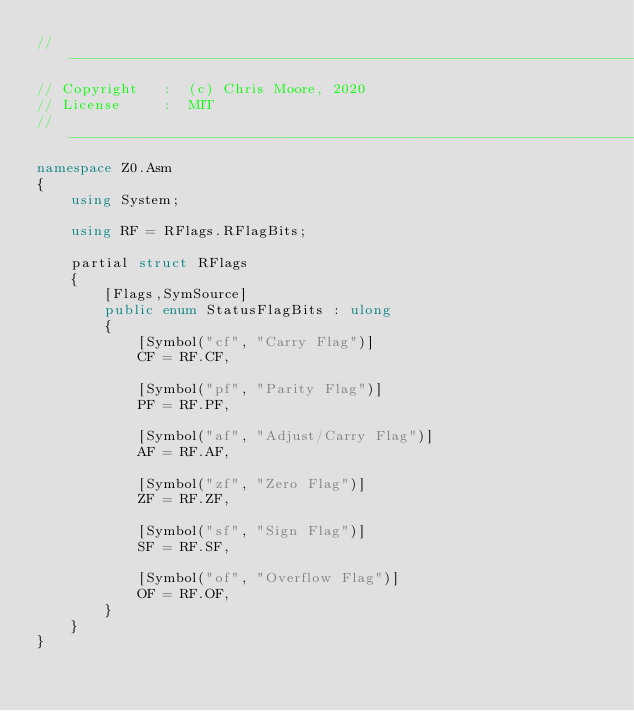<code> <loc_0><loc_0><loc_500><loc_500><_C#_>//-----------------------------------------------------------------------------
// Copyright   :  (c) Chris Moore, 2020
// License     :  MIT
//-----------------------------------------------------------------------------
namespace Z0.Asm
{
    using System;

    using RF = RFlags.RFlagBits;

    partial struct RFlags
    {
        [Flags,SymSource]
        public enum StatusFlagBits : ulong
        {
            [Symbol("cf", "Carry Flag")]
            CF = RF.CF,

            [Symbol("pf", "Parity Flag")]
            PF = RF.PF,

            [Symbol("af", "Adjust/Carry Flag")]
            AF = RF.AF,

            [Symbol("zf", "Zero Flag")]
            ZF = RF.ZF,

            [Symbol("sf", "Sign Flag")]
            SF = RF.SF,

            [Symbol("of", "Overflow Flag")]
            OF = RF.OF,
        }
    }
}</code> 